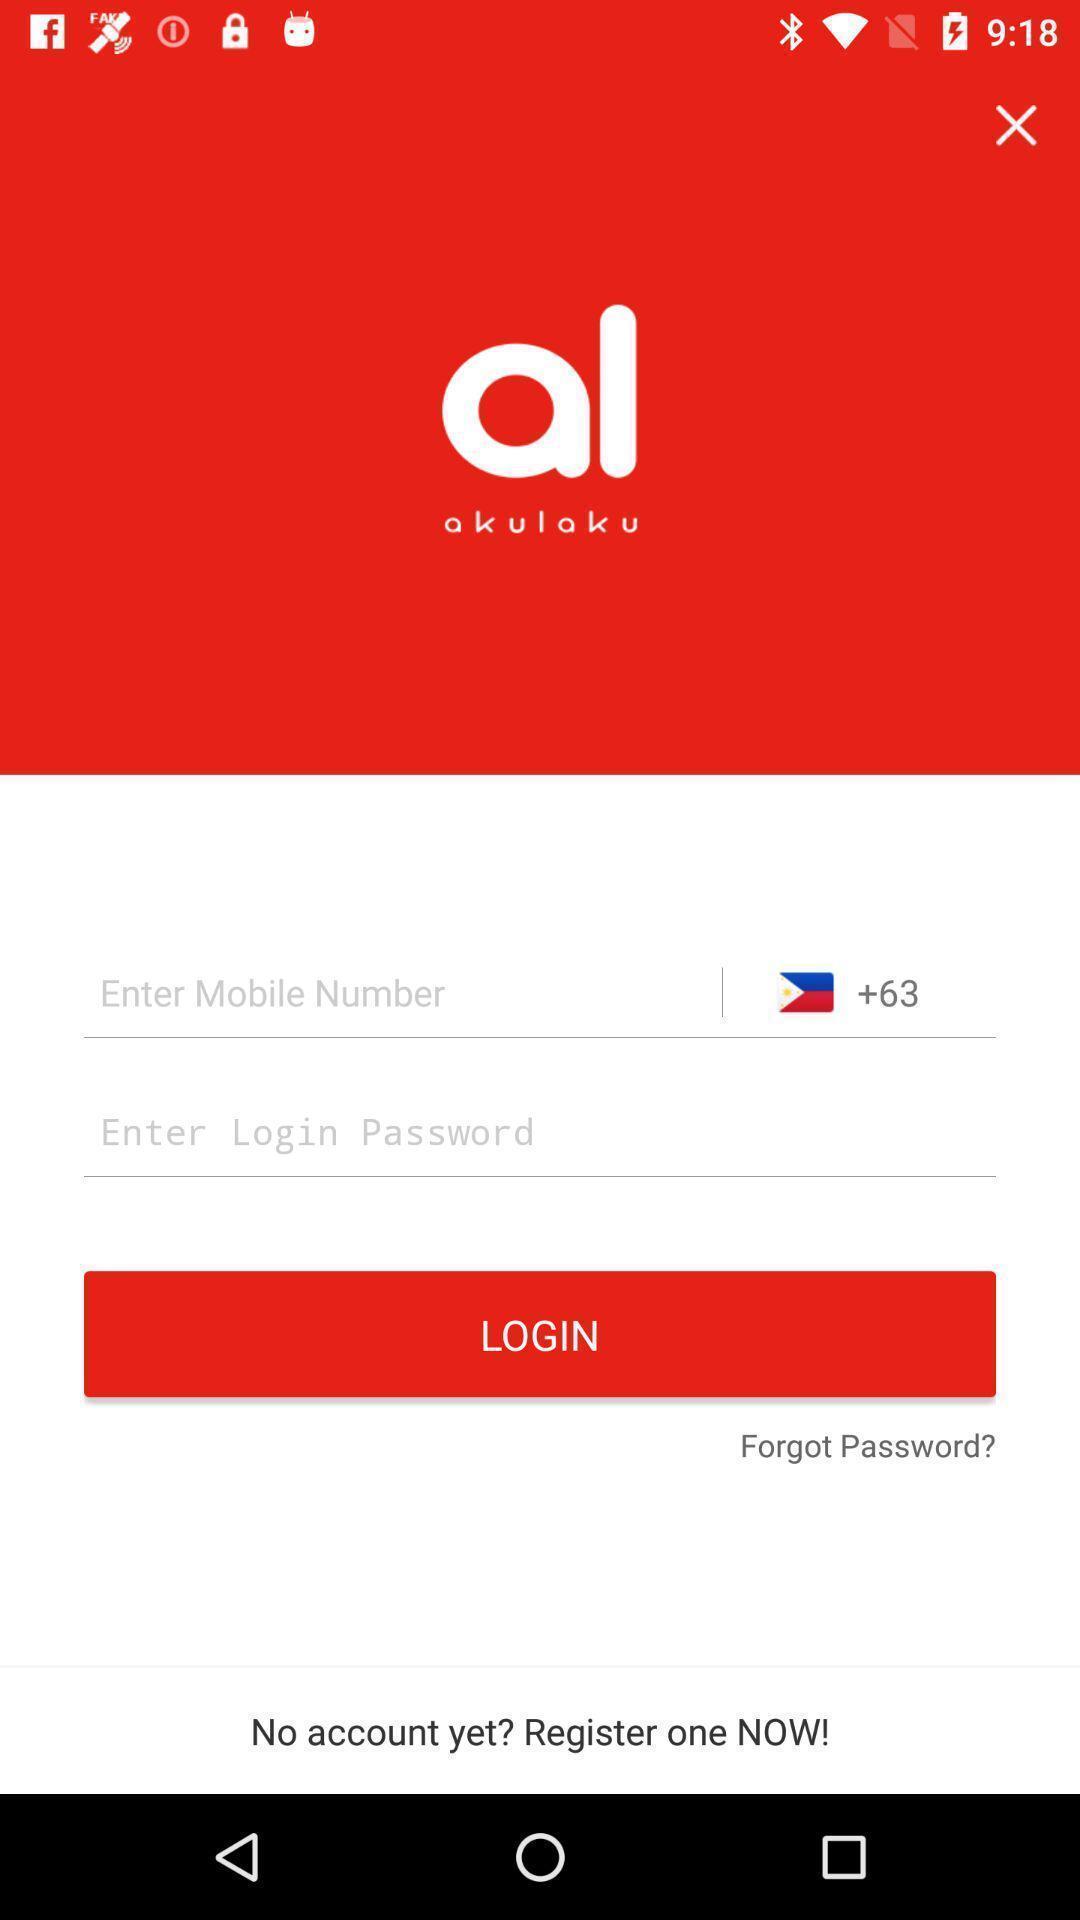Describe the visual elements of this screenshot. Page displaying login option. 